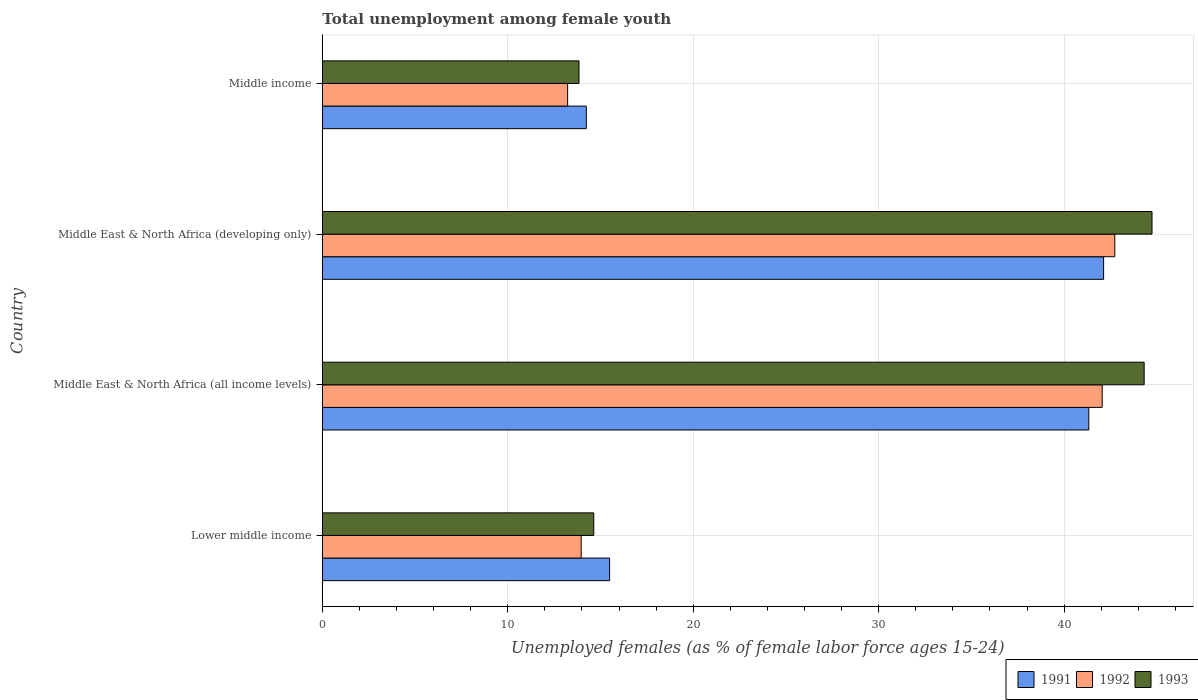How many groups of bars are there?
Make the answer very short. 4. How many bars are there on the 2nd tick from the bottom?
Your answer should be compact. 3. What is the label of the 3rd group of bars from the top?
Your answer should be compact. Middle East & North Africa (all income levels). What is the percentage of unemployed females in in 1992 in Middle East & North Africa (developing only)?
Keep it short and to the point. 42.73. Across all countries, what is the maximum percentage of unemployed females in in 1991?
Make the answer very short. 42.13. Across all countries, what is the minimum percentage of unemployed females in in 1992?
Your response must be concise. 13.23. In which country was the percentage of unemployed females in in 1993 maximum?
Your answer should be very brief. Middle East & North Africa (developing only). What is the total percentage of unemployed females in in 1992 in the graph?
Provide a short and direct response. 111.98. What is the difference between the percentage of unemployed females in in 1993 in Lower middle income and that in Middle East & North Africa (all income levels)?
Make the answer very short. -29.68. What is the difference between the percentage of unemployed females in in 1992 in Middle income and the percentage of unemployed females in in 1993 in Lower middle income?
Ensure brevity in your answer.  -1.41. What is the average percentage of unemployed females in in 1992 per country?
Ensure brevity in your answer.  27.99. What is the difference between the percentage of unemployed females in in 1992 and percentage of unemployed females in in 1993 in Middle East & North Africa (developing only)?
Your response must be concise. -2.01. What is the ratio of the percentage of unemployed females in in 1993 in Lower middle income to that in Middle income?
Offer a terse response. 1.06. What is the difference between the highest and the second highest percentage of unemployed females in in 1993?
Make the answer very short. 0.42. What is the difference between the highest and the lowest percentage of unemployed females in in 1991?
Provide a succinct answer. 27.9. In how many countries, is the percentage of unemployed females in in 1993 greater than the average percentage of unemployed females in in 1993 taken over all countries?
Provide a short and direct response. 2. What does the 1st bar from the top in Middle East & North Africa (all income levels) represents?
Give a very brief answer. 1993. How many bars are there?
Your answer should be very brief. 12. How many countries are there in the graph?
Your answer should be compact. 4. Does the graph contain any zero values?
Provide a succinct answer. No. Does the graph contain grids?
Make the answer very short. Yes. What is the title of the graph?
Your answer should be very brief. Total unemployment among female youth. Does "2002" appear as one of the legend labels in the graph?
Provide a short and direct response. No. What is the label or title of the X-axis?
Keep it short and to the point. Unemployed females (as % of female labor force ages 15-24). What is the Unemployed females (as % of female labor force ages 15-24) in 1991 in Lower middle income?
Give a very brief answer. 15.49. What is the Unemployed females (as % of female labor force ages 15-24) of 1992 in Lower middle income?
Provide a succinct answer. 13.96. What is the Unemployed females (as % of female labor force ages 15-24) in 1993 in Lower middle income?
Keep it short and to the point. 14.64. What is the Unemployed females (as % of female labor force ages 15-24) in 1991 in Middle East & North Africa (all income levels)?
Ensure brevity in your answer.  41.33. What is the Unemployed females (as % of female labor force ages 15-24) of 1992 in Middle East & North Africa (all income levels)?
Make the answer very short. 42.05. What is the Unemployed females (as % of female labor force ages 15-24) of 1993 in Middle East & North Africa (all income levels)?
Give a very brief answer. 44.32. What is the Unemployed females (as % of female labor force ages 15-24) in 1991 in Middle East & North Africa (developing only)?
Your answer should be very brief. 42.13. What is the Unemployed females (as % of female labor force ages 15-24) of 1992 in Middle East & North Africa (developing only)?
Your response must be concise. 42.73. What is the Unemployed females (as % of female labor force ages 15-24) in 1993 in Middle East & North Africa (developing only)?
Provide a succinct answer. 44.74. What is the Unemployed females (as % of female labor force ages 15-24) in 1991 in Middle income?
Offer a very short reply. 14.24. What is the Unemployed females (as % of female labor force ages 15-24) of 1992 in Middle income?
Provide a short and direct response. 13.23. What is the Unemployed females (as % of female labor force ages 15-24) in 1993 in Middle income?
Your answer should be compact. 13.84. Across all countries, what is the maximum Unemployed females (as % of female labor force ages 15-24) in 1991?
Offer a terse response. 42.13. Across all countries, what is the maximum Unemployed females (as % of female labor force ages 15-24) of 1992?
Provide a short and direct response. 42.73. Across all countries, what is the maximum Unemployed females (as % of female labor force ages 15-24) of 1993?
Ensure brevity in your answer.  44.74. Across all countries, what is the minimum Unemployed females (as % of female labor force ages 15-24) in 1991?
Ensure brevity in your answer.  14.24. Across all countries, what is the minimum Unemployed females (as % of female labor force ages 15-24) of 1992?
Offer a very short reply. 13.23. Across all countries, what is the minimum Unemployed females (as % of female labor force ages 15-24) of 1993?
Give a very brief answer. 13.84. What is the total Unemployed females (as % of female labor force ages 15-24) in 1991 in the graph?
Give a very brief answer. 113.19. What is the total Unemployed females (as % of female labor force ages 15-24) in 1992 in the graph?
Offer a terse response. 111.98. What is the total Unemployed females (as % of female labor force ages 15-24) of 1993 in the graph?
Give a very brief answer. 117.54. What is the difference between the Unemployed females (as % of female labor force ages 15-24) of 1991 in Lower middle income and that in Middle East & North Africa (all income levels)?
Offer a terse response. -25.84. What is the difference between the Unemployed females (as % of female labor force ages 15-24) in 1992 in Lower middle income and that in Middle East & North Africa (all income levels)?
Provide a short and direct response. -28.1. What is the difference between the Unemployed females (as % of female labor force ages 15-24) of 1993 in Lower middle income and that in Middle East & North Africa (all income levels)?
Make the answer very short. -29.68. What is the difference between the Unemployed females (as % of female labor force ages 15-24) of 1991 in Lower middle income and that in Middle East & North Africa (developing only)?
Offer a terse response. -26.64. What is the difference between the Unemployed females (as % of female labor force ages 15-24) in 1992 in Lower middle income and that in Middle East & North Africa (developing only)?
Make the answer very short. -28.77. What is the difference between the Unemployed females (as % of female labor force ages 15-24) in 1993 in Lower middle income and that in Middle East & North Africa (developing only)?
Keep it short and to the point. -30.1. What is the difference between the Unemployed females (as % of female labor force ages 15-24) in 1991 in Lower middle income and that in Middle income?
Offer a very short reply. 1.26. What is the difference between the Unemployed females (as % of female labor force ages 15-24) in 1992 in Lower middle income and that in Middle income?
Your response must be concise. 0.73. What is the difference between the Unemployed females (as % of female labor force ages 15-24) in 1993 in Lower middle income and that in Middle income?
Offer a terse response. 0.8. What is the difference between the Unemployed females (as % of female labor force ages 15-24) of 1991 in Middle East & North Africa (all income levels) and that in Middle East & North Africa (developing only)?
Provide a short and direct response. -0.8. What is the difference between the Unemployed females (as % of female labor force ages 15-24) of 1992 in Middle East & North Africa (all income levels) and that in Middle East & North Africa (developing only)?
Your answer should be very brief. -0.68. What is the difference between the Unemployed females (as % of female labor force ages 15-24) of 1993 in Middle East & North Africa (all income levels) and that in Middle East & North Africa (developing only)?
Offer a terse response. -0.42. What is the difference between the Unemployed females (as % of female labor force ages 15-24) in 1991 in Middle East & North Africa (all income levels) and that in Middle income?
Keep it short and to the point. 27.1. What is the difference between the Unemployed females (as % of female labor force ages 15-24) in 1992 in Middle East & North Africa (all income levels) and that in Middle income?
Your answer should be compact. 28.83. What is the difference between the Unemployed females (as % of female labor force ages 15-24) of 1993 in Middle East & North Africa (all income levels) and that in Middle income?
Keep it short and to the point. 30.48. What is the difference between the Unemployed females (as % of female labor force ages 15-24) of 1991 in Middle East & North Africa (developing only) and that in Middle income?
Your response must be concise. 27.9. What is the difference between the Unemployed females (as % of female labor force ages 15-24) in 1992 in Middle East & North Africa (developing only) and that in Middle income?
Your response must be concise. 29.51. What is the difference between the Unemployed females (as % of female labor force ages 15-24) in 1993 in Middle East & North Africa (developing only) and that in Middle income?
Your answer should be compact. 30.9. What is the difference between the Unemployed females (as % of female labor force ages 15-24) in 1991 in Lower middle income and the Unemployed females (as % of female labor force ages 15-24) in 1992 in Middle East & North Africa (all income levels)?
Ensure brevity in your answer.  -26.56. What is the difference between the Unemployed females (as % of female labor force ages 15-24) in 1991 in Lower middle income and the Unemployed females (as % of female labor force ages 15-24) in 1993 in Middle East & North Africa (all income levels)?
Your answer should be compact. -28.83. What is the difference between the Unemployed females (as % of female labor force ages 15-24) in 1992 in Lower middle income and the Unemployed females (as % of female labor force ages 15-24) in 1993 in Middle East & North Africa (all income levels)?
Make the answer very short. -30.36. What is the difference between the Unemployed females (as % of female labor force ages 15-24) of 1991 in Lower middle income and the Unemployed females (as % of female labor force ages 15-24) of 1992 in Middle East & North Africa (developing only)?
Give a very brief answer. -27.24. What is the difference between the Unemployed females (as % of female labor force ages 15-24) of 1991 in Lower middle income and the Unemployed females (as % of female labor force ages 15-24) of 1993 in Middle East & North Africa (developing only)?
Provide a short and direct response. -29.25. What is the difference between the Unemployed females (as % of female labor force ages 15-24) in 1992 in Lower middle income and the Unemployed females (as % of female labor force ages 15-24) in 1993 in Middle East & North Africa (developing only)?
Make the answer very short. -30.78. What is the difference between the Unemployed females (as % of female labor force ages 15-24) of 1991 in Lower middle income and the Unemployed females (as % of female labor force ages 15-24) of 1992 in Middle income?
Your answer should be very brief. 2.26. What is the difference between the Unemployed females (as % of female labor force ages 15-24) of 1991 in Lower middle income and the Unemployed females (as % of female labor force ages 15-24) of 1993 in Middle income?
Keep it short and to the point. 1.65. What is the difference between the Unemployed females (as % of female labor force ages 15-24) of 1992 in Lower middle income and the Unemployed females (as % of female labor force ages 15-24) of 1993 in Middle income?
Offer a very short reply. 0.12. What is the difference between the Unemployed females (as % of female labor force ages 15-24) of 1991 in Middle East & North Africa (all income levels) and the Unemployed females (as % of female labor force ages 15-24) of 1992 in Middle East & North Africa (developing only)?
Your response must be concise. -1.4. What is the difference between the Unemployed females (as % of female labor force ages 15-24) in 1991 in Middle East & North Africa (all income levels) and the Unemployed females (as % of female labor force ages 15-24) in 1993 in Middle East & North Africa (developing only)?
Keep it short and to the point. -3.41. What is the difference between the Unemployed females (as % of female labor force ages 15-24) of 1992 in Middle East & North Africa (all income levels) and the Unemployed females (as % of female labor force ages 15-24) of 1993 in Middle East & North Africa (developing only)?
Offer a terse response. -2.69. What is the difference between the Unemployed females (as % of female labor force ages 15-24) in 1991 in Middle East & North Africa (all income levels) and the Unemployed females (as % of female labor force ages 15-24) in 1992 in Middle income?
Give a very brief answer. 28.1. What is the difference between the Unemployed females (as % of female labor force ages 15-24) in 1991 in Middle East & North Africa (all income levels) and the Unemployed females (as % of female labor force ages 15-24) in 1993 in Middle income?
Your answer should be very brief. 27.49. What is the difference between the Unemployed females (as % of female labor force ages 15-24) of 1992 in Middle East & North Africa (all income levels) and the Unemployed females (as % of female labor force ages 15-24) of 1993 in Middle income?
Provide a short and direct response. 28.21. What is the difference between the Unemployed females (as % of female labor force ages 15-24) in 1991 in Middle East & North Africa (developing only) and the Unemployed females (as % of female labor force ages 15-24) in 1992 in Middle income?
Provide a short and direct response. 28.9. What is the difference between the Unemployed females (as % of female labor force ages 15-24) in 1991 in Middle East & North Africa (developing only) and the Unemployed females (as % of female labor force ages 15-24) in 1993 in Middle income?
Provide a succinct answer. 28.29. What is the difference between the Unemployed females (as % of female labor force ages 15-24) in 1992 in Middle East & North Africa (developing only) and the Unemployed females (as % of female labor force ages 15-24) in 1993 in Middle income?
Keep it short and to the point. 28.89. What is the average Unemployed females (as % of female labor force ages 15-24) of 1991 per country?
Offer a terse response. 28.3. What is the average Unemployed females (as % of female labor force ages 15-24) in 1992 per country?
Give a very brief answer. 27.99. What is the average Unemployed females (as % of female labor force ages 15-24) of 1993 per country?
Provide a succinct answer. 29.38. What is the difference between the Unemployed females (as % of female labor force ages 15-24) in 1991 and Unemployed females (as % of female labor force ages 15-24) in 1992 in Lower middle income?
Provide a succinct answer. 1.53. What is the difference between the Unemployed females (as % of female labor force ages 15-24) of 1991 and Unemployed females (as % of female labor force ages 15-24) of 1993 in Lower middle income?
Make the answer very short. 0.85. What is the difference between the Unemployed females (as % of female labor force ages 15-24) in 1992 and Unemployed females (as % of female labor force ages 15-24) in 1993 in Lower middle income?
Ensure brevity in your answer.  -0.68. What is the difference between the Unemployed females (as % of female labor force ages 15-24) of 1991 and Unemployed females (as % of female labor force ages 15-24) of 1992 in Middle East & North Africa (all income levels)?
Your response must be concise. -0.72. What is the difference between the Unemployed females (as % of female labor force ages 15-24) in 1991 and Unemployed females (as % of female labor force ages 15-24) in 1993 in Middle East & North Africa (all income levels)?
Your answer should be very brief. -2.99. What is the difference between the Unemployed females (as % of female labor force ages 15-24) of 1992 and Unemployed females (as % of female labor force ages 15-24) of 1993 in Middle East & North Africa (all income levels)?
Give a very brief answer. -2.26. What is the difference between the Unemployed females (as % of female labor force ages 15-24) in 1991 and Unemployed females (as % of female labor force ages 15-24) in 1992 in Middle East & North Africa (developing only)?
Offer a terse response. -0.6. What is the difference between the Unemployed females (as % of female labor force ages 15-24) in 1991 and Unemployed females (as % of female labor force ages 15-24) in 1993 in Middle East & North Africa (developing only)?
Ensure brevity in your answer.  -2.61. What is the difference between the Unemployed females (as % of female labor force ages 15-24) of 1992 and Unemployed females (as % of female labor force ages 15-24) of 1993 in Middle East & North Africa (developing only)?
Provide a short and direct response. -2.01. What is the difference between the Unemployed females (as % of female labor force ages 15-24) in 1991 and Unemployed females (as % of female labor force ages 15-24) in 1992 in Middle income?
Keep it short and to the point. 1.01. What is the difference between the Unemployed females (as % of female labor force ages 15-24) in 1991 and Unemployed females (as % of female labor force ages 15-24) in 1993 in Middle income?
Offer a very short reply. 0.4. What is the difference between the Unemployed females (as % of female labor force ages 15-24) of 1992 and Unemployed females (as % of female labor force ages 15-24) of 1993 in Middle income?
Give a very brief answer. -0.61. What is the ratio of the Unemployed females (as % of female labor force ages 15-24) in 1991 in Lower middle income to that in Middle East & North Africa (all income levels)?
Provide a succinct answer. 0.37. What is the ratio of the Unemployed females (as % of female labor force ages 15-24) of 1992 in Lower middle income to that in Middle East & North Africa (all income levels)?
Offer a very short reply. 0.33. What is the ratio of the Unemployed females (as % of female labor force ages 15-24) of 1993 in Lower middle income to that in Middle East & North Africa (all income levels)?
Offer a very short reply. 0.33. What is the ratio of the Unemployed females (as % of female labor force ages 15-24) in 1991 in Lower middle income to that in Middle East & North Africa (developing only)?
Make the answer very short. 0.37. What is the ratio of the Unemployed females (as % of female labor force ages 15-24) of 1992 in Lower middle income to that in Middle East & North Africa (developing only)?
Ensure brevity in your answer.  0.33. What is the ratio of the Unemployed females (as % of female labor force ages 15-24) in 1993 in Lower middle income to that in Middle East & North Africa (developing only)?
Make the answer very short. 0.33. What is the ratio of the Unemployed females (as % of female labor force ages 15-24) in 1991 in Lower middle income to that in Middle income?
Provide a succinct answer. 1.09. What is the ratio of the Unemployed females (as % of female labor force ages 15-24) of 1992 in Lower middle income to that in Middle income?
Give a very brief answer. 1.06. What is the ratio of the Unemployed females (as % of female labor force ages 15-24) in 1993 in Lower middle income to that in Middle income?
Offer a terse response. 1.06. What is the ratio of the Unemployed females (as % of female labor force ages 15-24) in 1992 in Middle East & North Africa (all income levels) to that in Middle East & North Africa (developing only)?
Ensure brevity in your answer.  0.98. What is the ratio of the Unemployed females (as % of female labor force ages 15-24) of 1991 in Middle East & North Africa (all income levels) to that in Middle income?
Give a very brief answer. 2.9. What is the ratio of the Unemployed females (as % of female labor force ages 15-24) of 1992 in Middle East & North Africa (all income levels) to that in Middle income?
Keep it short and to the point. 3.18. What is the ratio of the Unemployed females (as % of female labor force ages 15-24) of 1993 in Middle East & North Africa (all income levels) to that in Middle income?
Offer a very short reply. 3.2. What is the ratio of the Unemployed females (as % of female labor force ages 15-24) of 1991 in Middle East & North Africa (developing only) to that in Middle income?
Provide a succinct answer. 2.96. What is the ratio of the Unemployed females (as % of female labor force ages 15-24) in 1992 in Middle East & North Africa (developing only) to that in Middle income?
Offer a very short reply. 3.23. What is the ratio of the Unemployed females (as % of female labor force ages 15-24) in 1993 in Middle East & North Africa (developing only) to that in Middle income?
Make the answer very short. 3.23. What is the difference between the highest and the second highest Unemployed females (as % of female labor force ages 15-24) of 1991?
Make the answer very short. 0.8. What is the difference between the highest and the second highest Unemployed females (as % of female labor force ages 15-24) of 1992?
Keep it short and to the point. 0.68. What is the difference between the highest and the second highest Unemployed females (as % of female labor force ages 15-24) of 1993?
Give a very brief answer. 0.42. What is the difference between the highest and the lowest Unemployed females (as % of female labor force ages 15-24) of 1991?
Your response must be concise. 27.9. What is the difference between the highest and the lowest Unemployed females (as % of female labor force ages 15-24) in 1992?
Your answer should be very brief. 29.51. What is the difference between the highest and the lowest Unemployed females (as % of female labor force ages 15-24) in 1993?
Your answer should be very brief. 30.9. 